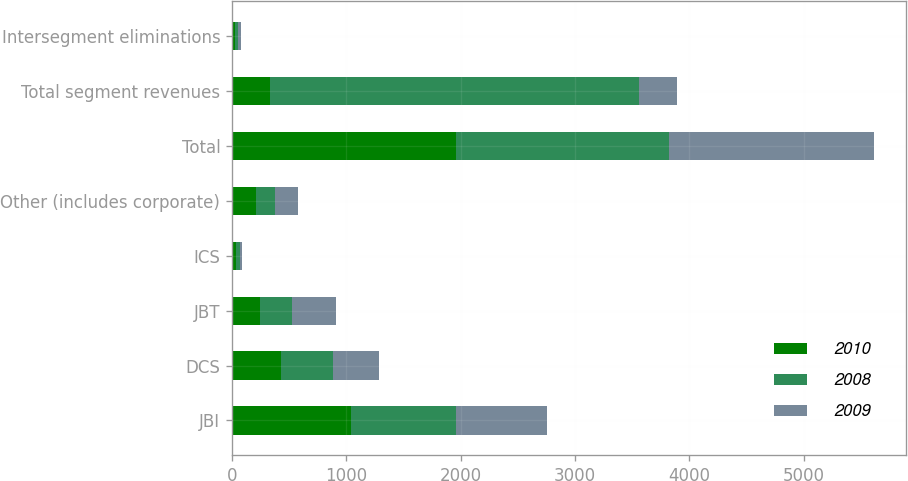Convert chart. <chart><loc_0><loc_0><loc_500><loc_500><stacked_bar_chart><ecel><fcel>JBI<fcel>DCS<fcel>JBT<fcel>ICS<fcel>Other (includes corporate)<fcel>Total<fcel>Total segment revenues<fcel>Intersegment eliminations<nl><fcel>2010<fcel>1042<fcel>433<fcel>245<fcel>36<fcel>206<fcel>1962<fcel>331<fcel>25<nl><fcel>2008<fcel>918<fcel>454<fcel>282<fcel>30<fcel>173<fcel>1857<fcel>3227<fcel>24<nl><fcel>2009<fcel>793<fcel>399<fcel>380<fcel>24<fcel>197<fcel>1793<fcel>331<fcel>32<nl></chart> 